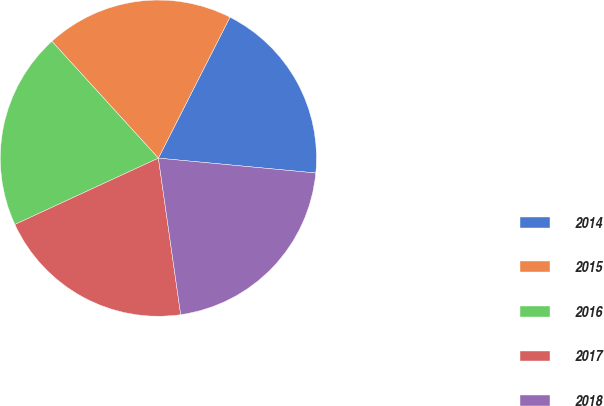Convert chart. <chart><loc_0><loc_0><loc_500><loc_500><pie_chart><fcel>2014<fcel>2015<fcel>2016<fcel>2017<fcel>2018<nl><fcel>19.02%<fcel>19.24%<fcel>20.13%<fcel>20.36%<fcel>21.25%<nl></chart> 